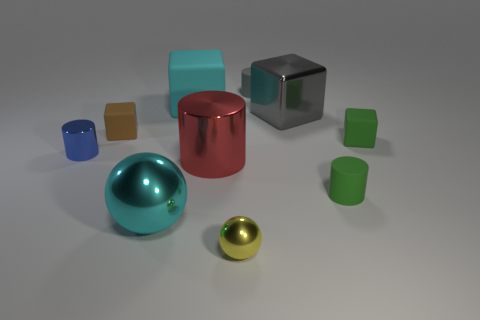What is the color of the block that is both left of the big gray metal cube and behind the small brown matte object?
Your answer should be compact. Cyan. What number of other things are made of the same material as the gray cylinder?
Provide a short and direct response. 4. Are there fewer large red metallic cylinders than small metallic blocks?
Provide a succinct answer. No. Do the tiny blue thing and the large block on the left side of the yellow metallic thing have the same material?
Your response must be concise. No. What is the shape of the cyan thing that is to the left of the big cyan rubber object?
Give a very brief answer. Sphere. Is there any other thing that has the same color as the small sphere?
Ensure brevity in your answer.  No. Are there fewer yellow metallic things that are in front of the cyan ball than big red cylinders?
Ensure brevity in your answer.  No. What number of gray matte objects have the same size as the yellow metal thing?
Offer a very short reply. 1. There is another thing that is the same color as the large rubber thing; what is its shape?
Offer a terse response. Sphere. There is a rubber thing on the right side of the green rubber object in front of the small rubber cube on the right side of the large gray metal thing; what is its shape?
Offer a terse response. Cube. 